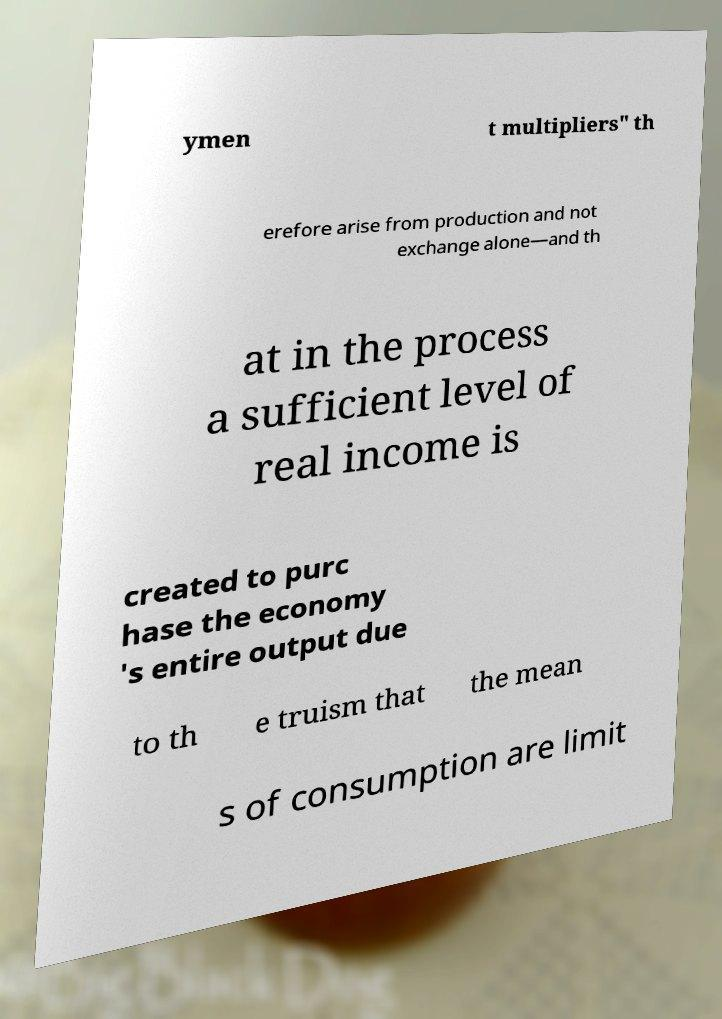There's text embedded in this image that I need extracted. Can you transcribe it verbatim? ymen t multipliers" th erefore arise from production and not exchange alone—and th at in the process a sufficient level of real income is created to purc hase the economy 's entire output due to th e truism that the mean s of consumption are limit 